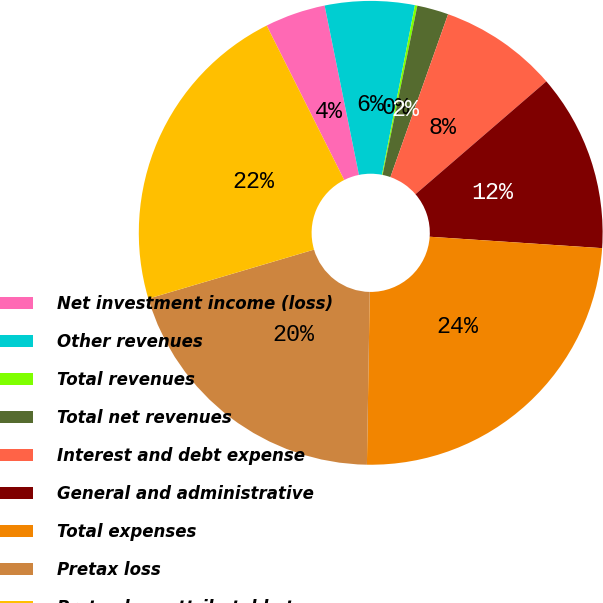Convert chart. <chart><loc_0><loc_0><loc_500><loc_500><pie_chart><fcel>Net investment income (loss)<fcel>Other revenues<fcel>Total revenues<fcel>Total net revenues<fcel>Interest and debt expense<fcel>General and administrative<fcel>Total expenses<fcel>Pretax loss<fcel>Pretax loss attributable to<nl><fcel>4.22%<fcel>6.24%<fcel>0.17%<fcel>2.19%<fcel>8.26%<fcel>12.38%<fcel>24.21%<fcel>20.16%<fcel>22.18%<nl></chart> 